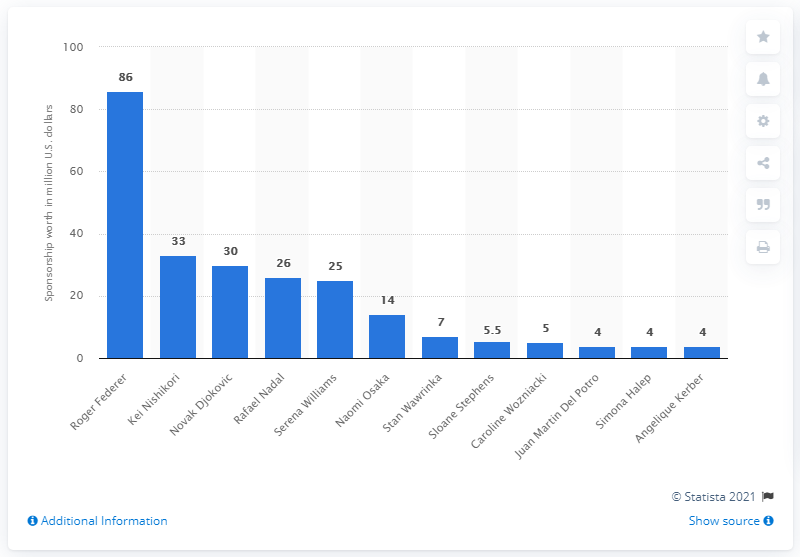Mention a couple of crucial points in this snapshot. Roger Federer has made a lucrative living off the court through numerous sponsorship deals, establishing himself as a successful and sought-after athlete in the world of tennis. According to estimates, Roger Federer's sponsorship is worth $86 million. 